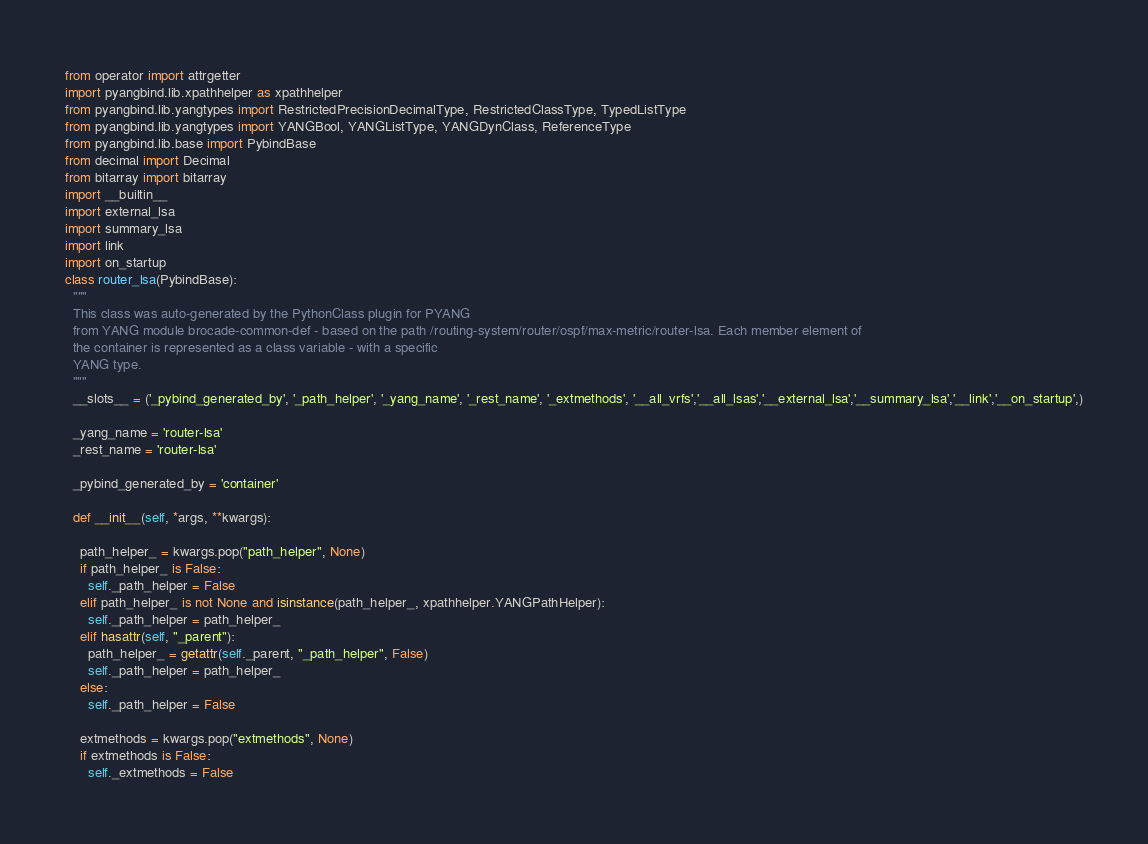<code> <loc_0><loc_0><loc_500><loc_500><_Python_>
from operator import attrgetter
import pyangbind.lib.xpathhelper as xpathhelper
from pyangbind.lib.yangtypes import RestrictedPrecisionDecimalType, RestrictedClassType, TypedListType
from pyangbind.lib.yangtypes import YANGBool, YANGListType, YANGDynClass, ReferenceType
from pyangbind.lib.base import PybindBase
from decimal import Decimal
from bitarray import bitarray
import __builtin__
import external_lsa
import summary_lsa
import link
import on_startup
class router_lsa(PybindBase):
  """
  This class was auto-generated by the PythonClass plugin for PYANG
  from YANG module brocade-common-def - based on the path /routing-system/router/ospf/max-metric/router-lsa. Each member element of
  the container is represented as a class variable - with a specific
  YANG type.
  """
  __slots__ = ('_pybind_generated_by', '_path_helper', '_yang_name', '_rest_name', '_extmethods', '__all_vrfs','__all_lsas','__external_lsa','__summary_lsa','__link','__on_startup',)

  _yang_name = 'router-lsa'
  _rest_name = 'router-lsa'

  _pybind_generated_by = 'container'

  def __init__(self, *args, **kwargs):

    path_helper_ = kwargs.pop("path_helper", None)
    if path_helper_ is False:
      self._path_helper = False
    elif path_helper_ is not None and isinstance(path_helper_, xpathhelper.YANGPathHelper):
      self._path_helper = path_helper_
    elif hasattr(self, "_parent"):
      path_helper_ = getattr(self._parent, "_path_helper", False)
      self._path_helper = path_helper_
    else:
      self._path_helper = False

    extmethods = kwargs.pop("extmethods", None)
    if extmethods is False:
      self._extmethods = False</code> 